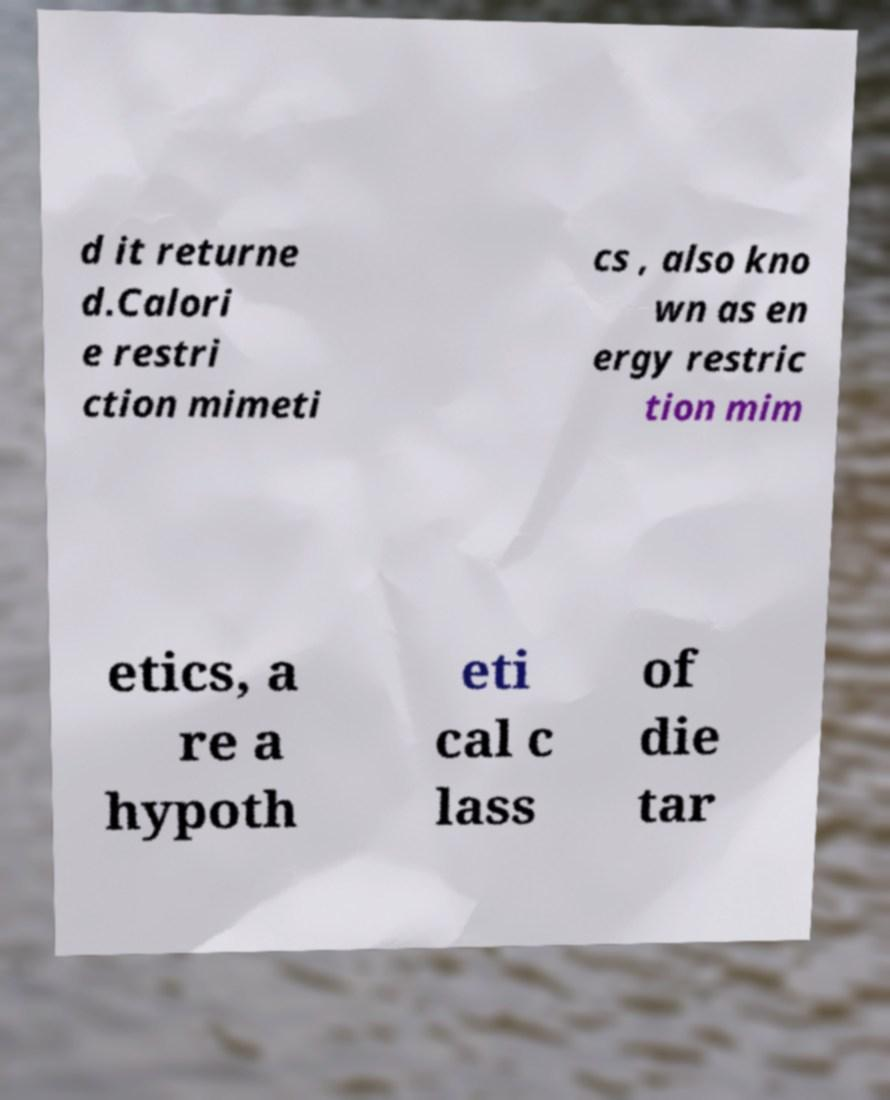Could you assist in decoding the text presented in this image and type it out clearly? d it returne d.Calori e restri ction mimeti cs , also kno wn as en ergy restric tion mim etics, a re a hypoth eti cal c lass of die tar 